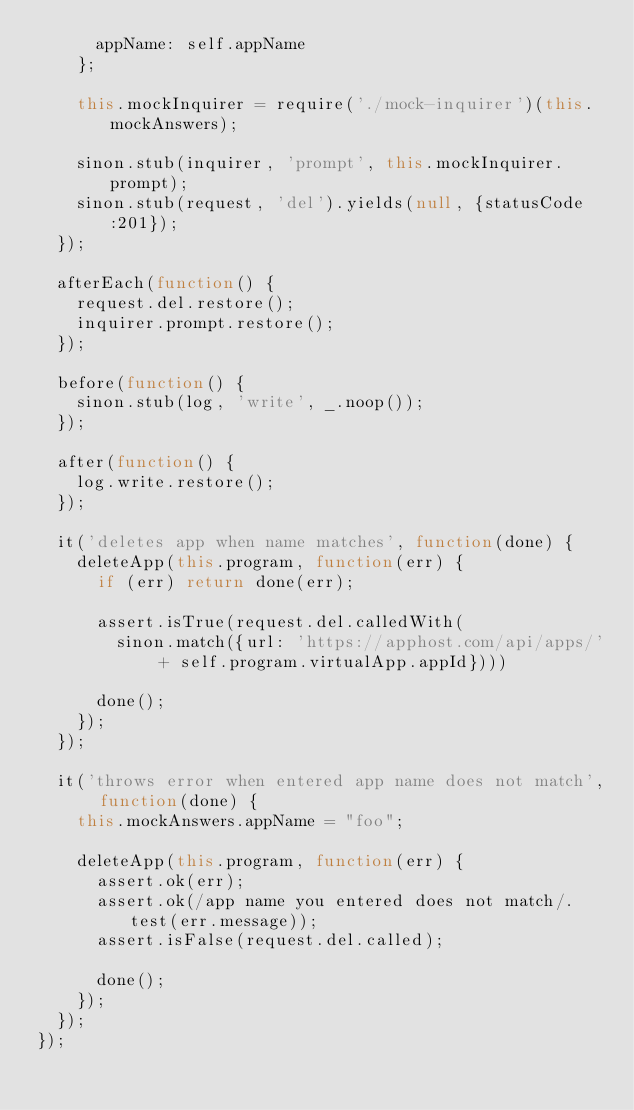<code> <loc_0><loc_0><loc_500><loc_500><_JavaScript_>      appName: self.appName
    };

    this.mockInquirer = require('./mock-inquirer')(this.mockAnswers);

    sinon.stub(inquirer, 'prompt', this.mockInquirer.prompt);
    sinon.stub(request, 'del').yields(null, {statusCode:201});
  });

  afterEach(function() {
    request.del.restore();
    inquirer.prompt.restore();
  });

  before(function() {
    sinon.stub(log, 'write', _.noop());
  });

  after(function() {
    log.write.restore();
  });

  it('deletes app when name matches', function(done) {
    deleteApp(this.program, function(err) {
      if (err) return done(err);

      assert.isTrue(request.del.calledWith(
        sinon.match({url: 'https://apphost.com/api/apps/' + self.program.virtualApp.appId})))

      done();
    });
  });

  it('throws error when entered app name does not match', function(done) {
    this.mockAnswers.appName = "foo";

    deleteApp(this.program, function(err) {
      assert.ok(err);
      assert.ok(/app name you entered does not match/.test(err.message));
      assert.isFalse(request.del.called);

      done();
    });
  });
});
</code> 